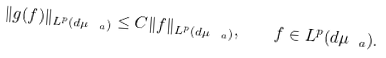<formula> <loc_0><loc_0><loc_500><loc_500>\| g ( f ) \| _ { L ^ { p } ( d \mu _ { \ a } ) } \leq C \| f \| _ { L ^ { p } ( d \mu _ { \ a } ) } , \quad f \in L ^ { p } ( d \mu _ { \ a } ) .</formula> 